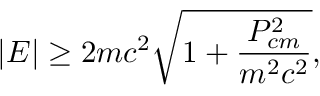Convert formula to latex. <formula><loc_0><loc_0><loc_500><loc_500>| E | \geq 2 m c ^ { 2 } \sqrt { 1 + \frac { P _ { c m } ^ { 2 } } { m ^ { 2 } c ^ { 2 } } } ,</formula> 